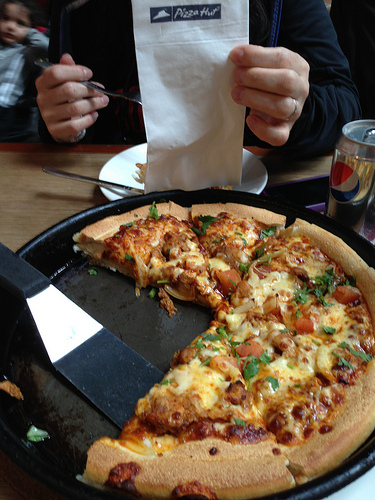Please provide the bounding box coordinate of the region this sentence describes: the plate with food on the table. The coordinates for the region describing the plate with food on the table are approximately [0.31, 0.26, 0.66, 0.4]. This should include the plate and the food on it, placed on the table. 